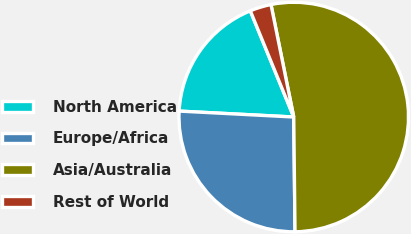Convert chart to OTSL. <chart><loc_0><loc_0><loc_500><loc_500><pie_chart><fcel>North America<fcel>Europe/Africa<fcel>Asia/Australia<fcel>Rest of World<nl><fcel>18.0%<fcel>26.0%<fcel>53.0%<fcel>3.0%<nl></chart> 